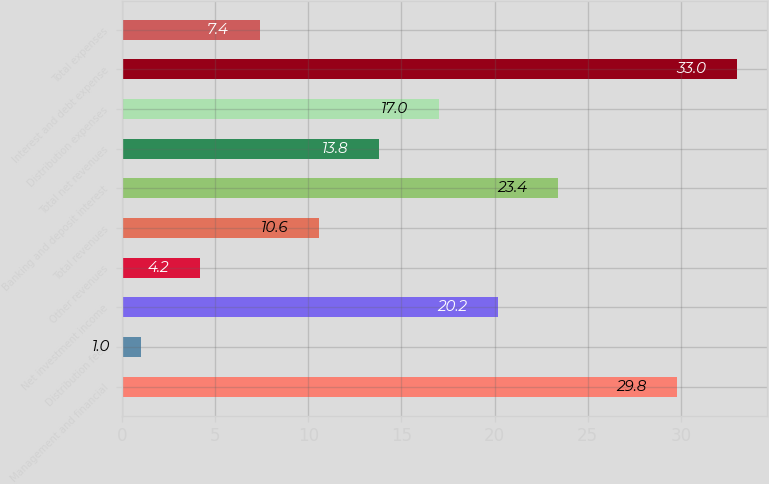Convert chart to OTSL. <chart><loc_0><loc_0><loc_500><loc_500><bar_chart><fcel>Management and financial<fcel>Distribution fees<fcel>Net investment income<fcel>Other revenues<fcel>Total revenues<fcel>Banking and deposit interest<fcel>Total net revenues<fcel>Distribution expenses<fcel>Interest and debt expense<fcel>Total expenses<nl><fcel>29.8<fcel>1<fcel>20.2<fcel>4.2<fcel>10.6<fcel>23.4<fcel>13.8<fcel>17<fcel>33<fcel>7.4<nl></chart> 